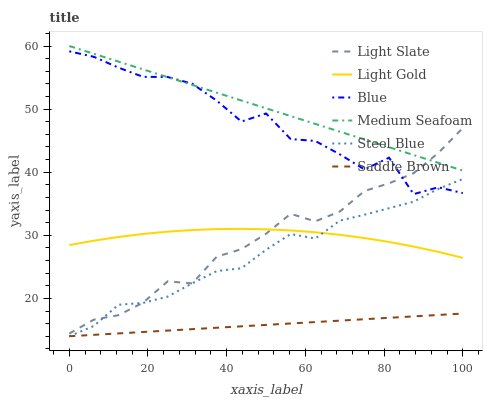Does Light Slate have the minimum area under the curve?
Answer yes or no. No. Does Light Slate have the maximum area under the curve?
Answer yes or no. No. Is Light Slate the smoothest?
Answer yes or no. No. Is Light Slate the roughest?
Answer yes or no. No. Does Light Slate have the lowest value?
Answer yes or no. No. Does Light Slate have the highest value?
Answer yes or no. No. Is Steel Blue less than Medium Seafoam?
Answer yes or no. Yes. Is Light Gold greater than Saddle Brown?
Answer yes or no. Yes. Does Steel Blue intersect Medium Seafoam?
Answer yes or no. No. 